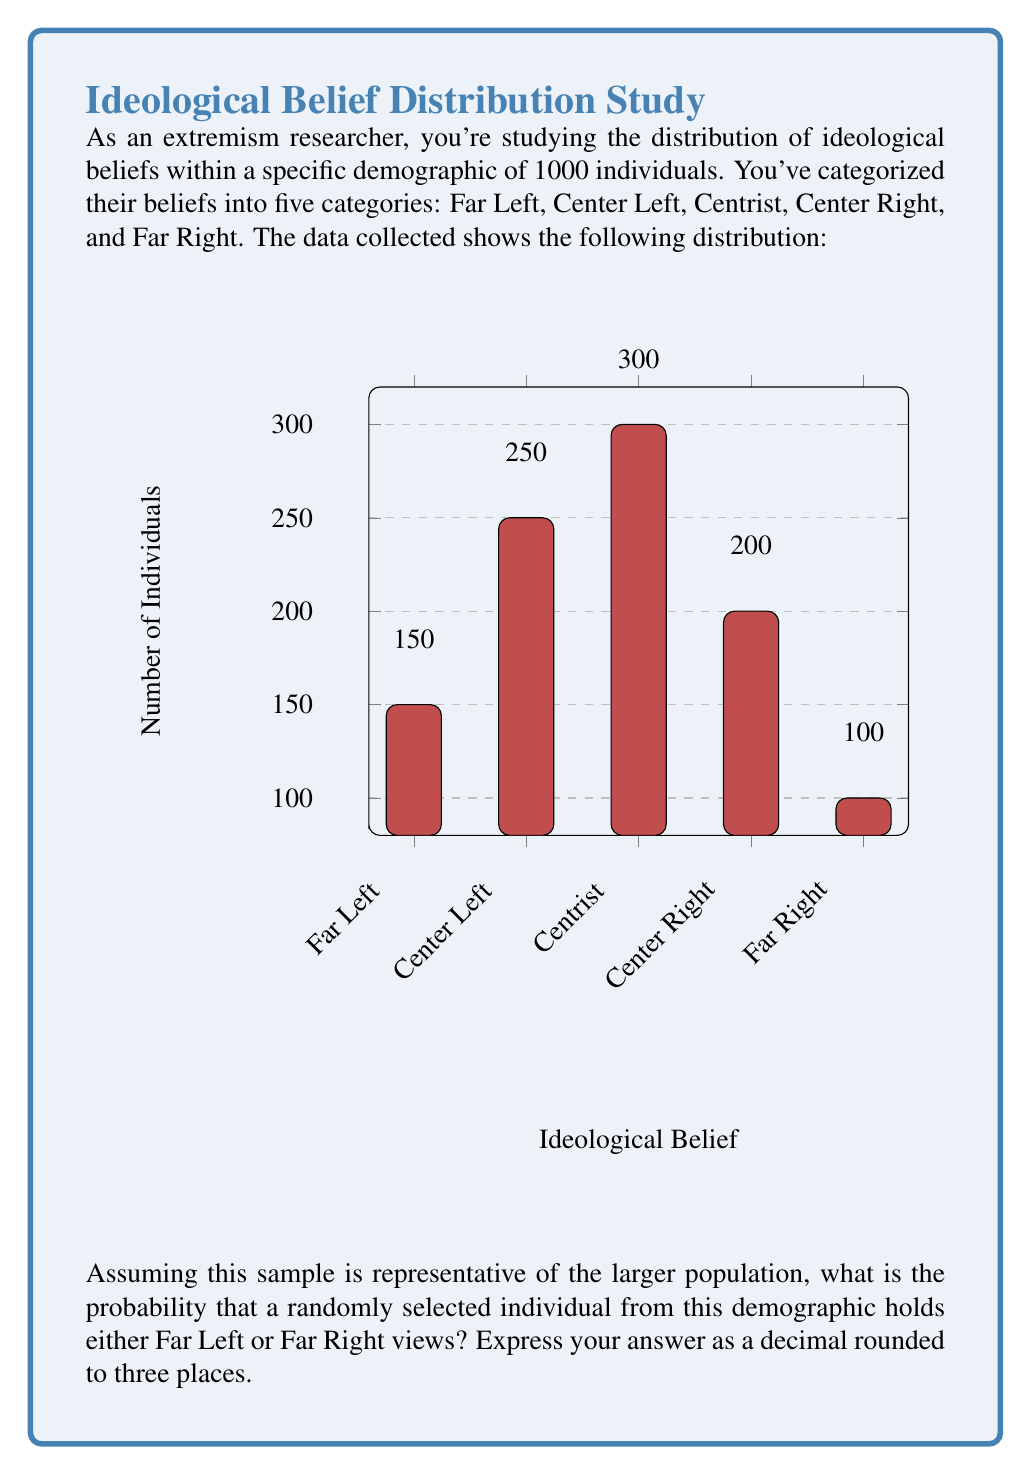Show me your answer to this math problem. To solve this problem, we need to follow these steps:

1) First, let's calculate the total number of individuals in the sample:
   $$150 + 250 + 300 + 200 + 100 = 1000$$

2) Now, we need to identify how many individuals hold Far Left or Far Right views:
   Far Left: 150
   Far Right: 100
   Total: $$150 + 100 = 250$$

3) The probability is calculated by dividing the number of favorable outcomes by the total number of possible outcomes:

   $$P(\text{Far Left or Far Right}) = \frac{\text{Number of Far Left and Far Right}}{\text{Total number of individuals}}$$

   $$P(\text{Far Left or Far Right}) = \frac{250}{1000} = 0.25$$

4) Rounding to three decimal places:
   0.25 remains 0.250

Therefore, the probability that a randomly selected individual holds either Far Left or Far Right views is 0.250 or 25%.
Answer: 0.250 